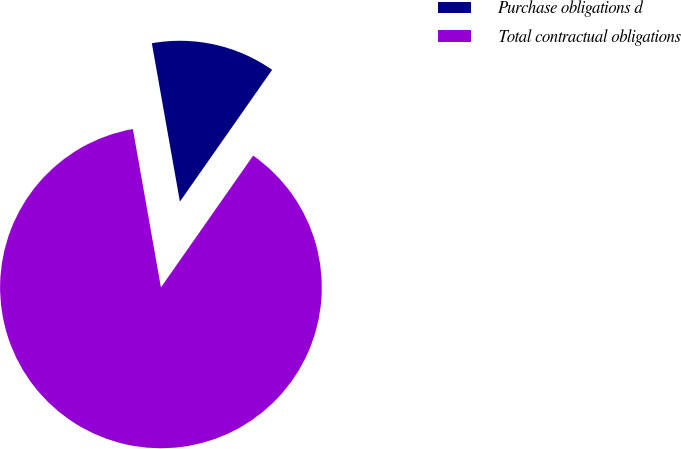<chart> <loc_0><loc_0><loc_500><loc_500><pie_chart><fcel>Purchase obligations d<fcel>Total contractual obligations<nl><fcel>12.51%<fcel>87.49%<nl></chart> 